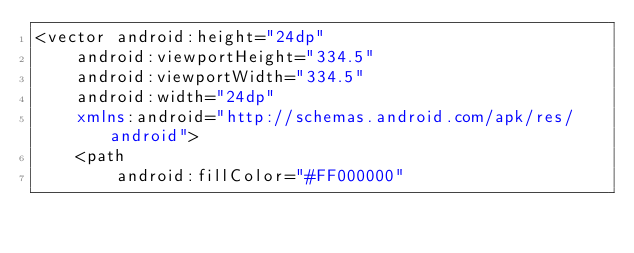Convert code to text. <code><loc_0><loc_0><loc_500><loc_500><_XML_><vector android:height="24dp"
    android:viewportHeight="334.5"
    android:viewportWidth="334.5"
    android:width="24dp"
    xmlns:android="http://schemas.android.com/apk/res/android">
    <path
        android:fillColor="#FF000000"</code> 